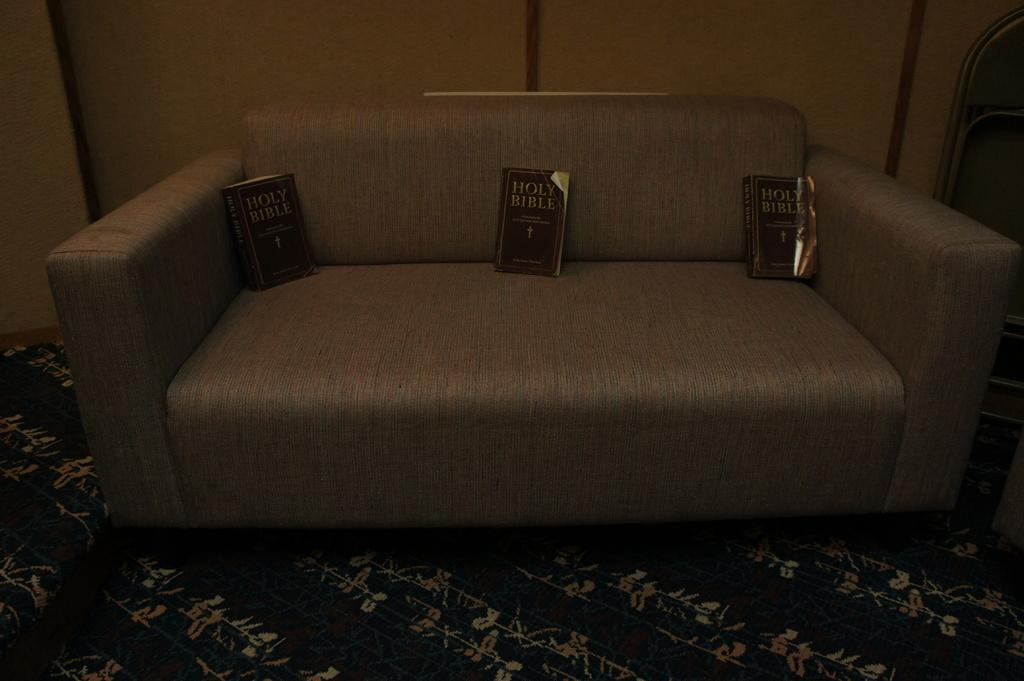What type of furniture is in the image? There is a sofa in the image. What is placed on the sofa? There are three books on the sofa. What can be seen in the background of the image? There is a wooden wall in the background of the image. Can you suggest a kick to perform while sitting on the sofa? There is no suggestion for a kick in the image, as it features a sofa with books on it and a wooden wall in the background. 